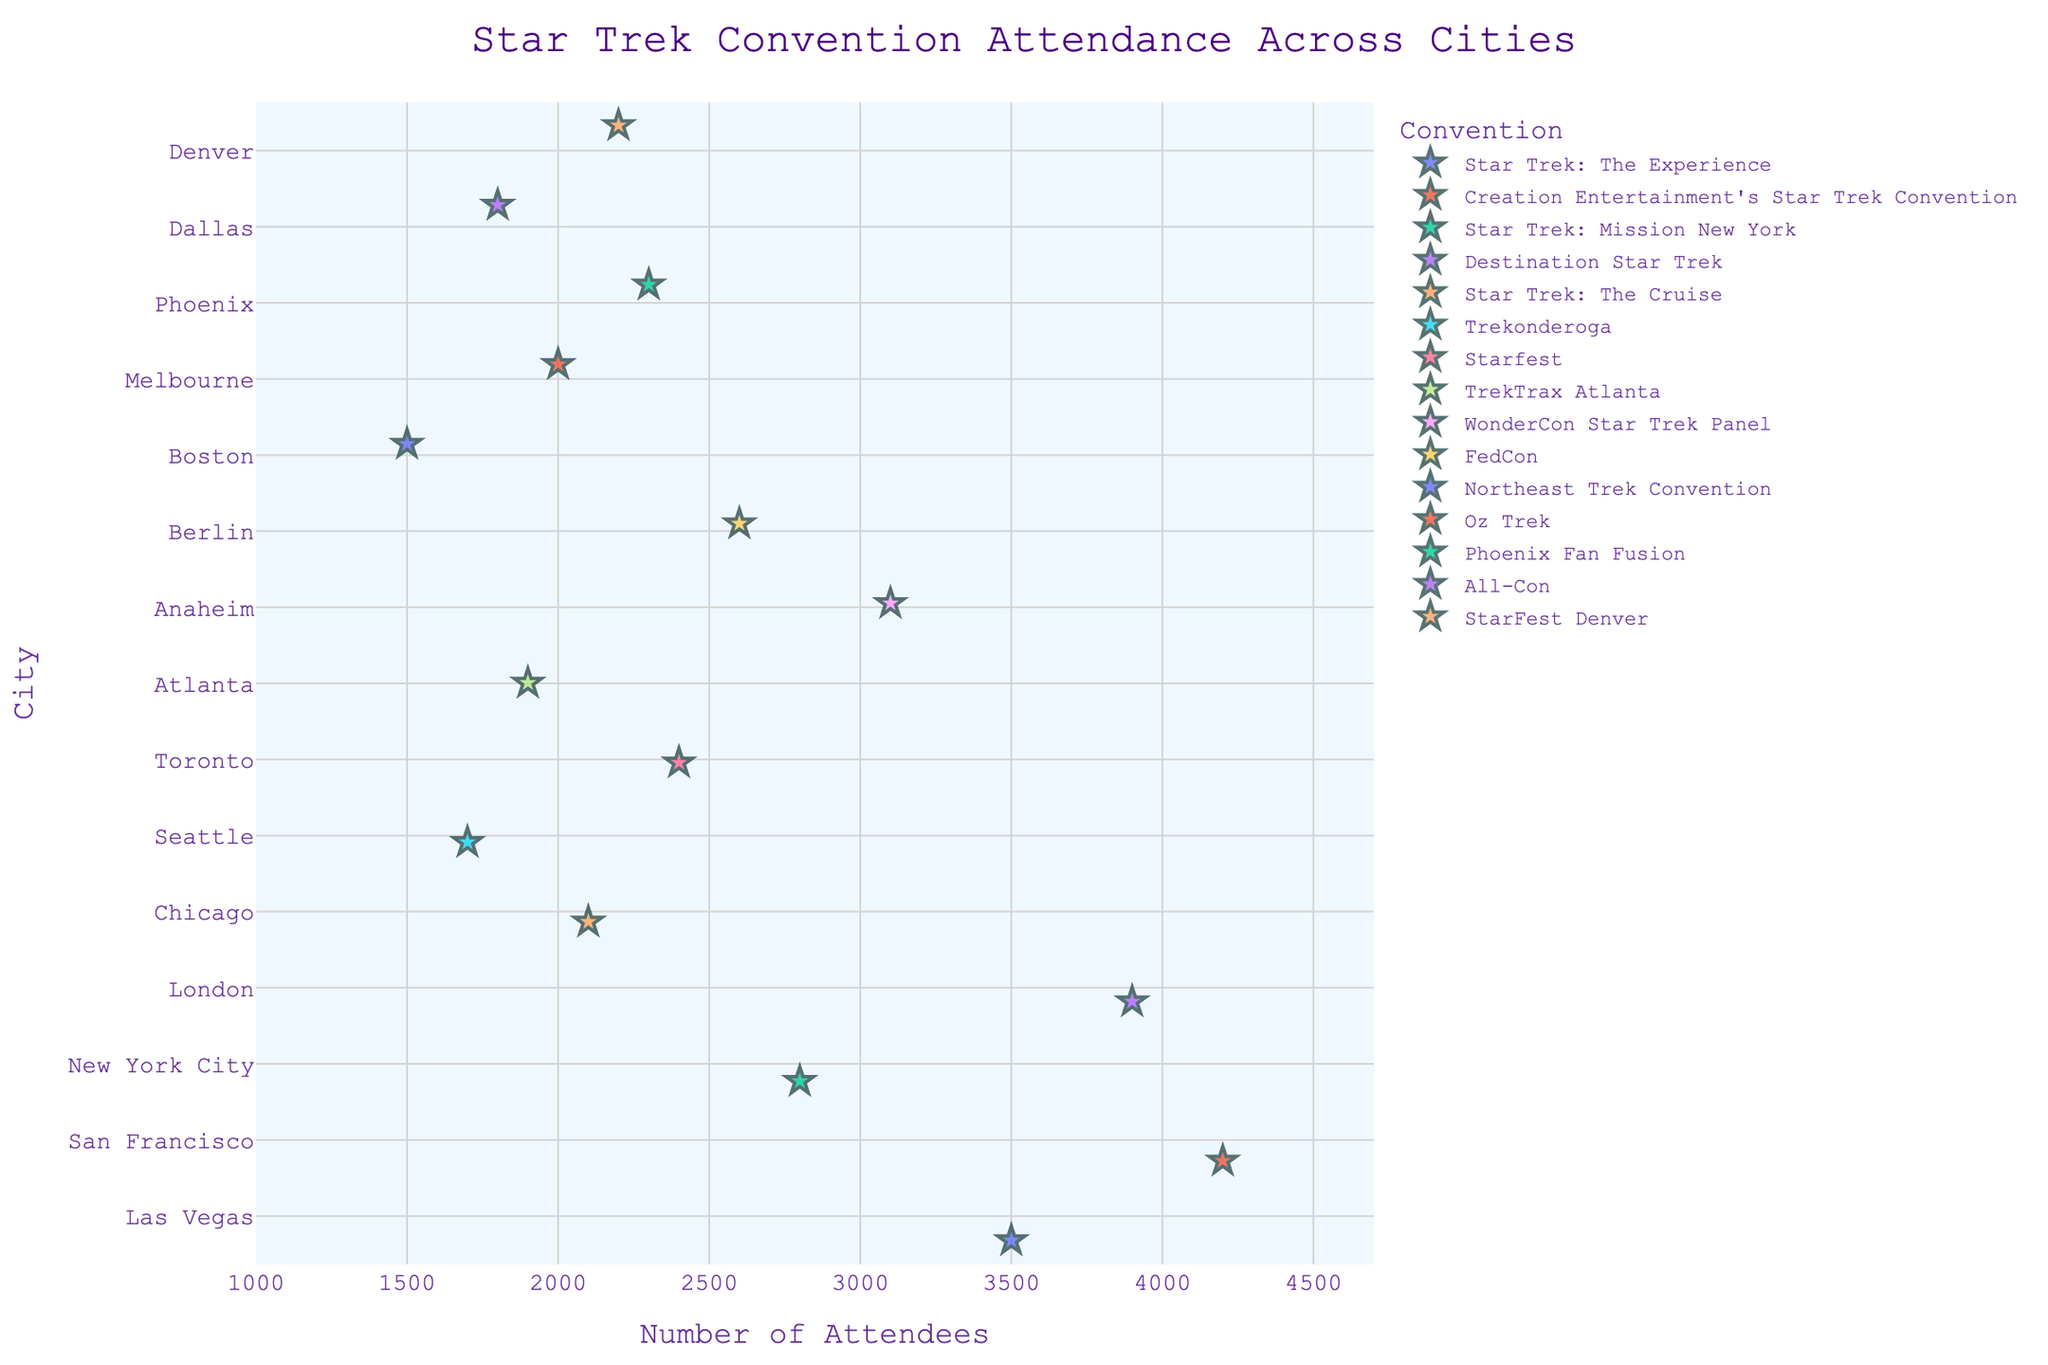How many cities are represented in the plot? Look at the y-axis to count the unique cities listed.
Answer: 15 What's the highest convention attendance, and in which city did it occur? Identify the point that is furthest to the right on the x-axis and then see which city it is aligned with on the y-axis.
Answer: 4200, San Francisco Which city had the lowest attendance, and what was the number? Identify the point that is furthest to the left on the x-axis and then see which city it is aligned with on the y-axis.
Answer: Boston, 1500 What is the range of attendance for the conventions shown? Subtract the smallest attendance value from the largest attendance value on the x-axis.
Answer: 4200 - 1500 = 2700 How many conventions had attendance greater than 3000? Count the number of points lying to the right side of the 3000 attendance mark on the x-axis.
Answer: 4 Which convention had the highest attendance, and what was the city? Look for the point with the highest x-axis value and identify the corresponding convention labeled by color and legend.
Answer: Creation Entertainment's Star Trek Convention, San Francisco Compare the attendance of "StarFest Denver" and "All-Con." Which one had more attendees and by how much? Identify the points for these conventions on the plot and compare their x-axis values. Then subtract the smaller attendance from the larger one.
Answer: StarFest Denver had more; difference is 2200 - 1800 = 400 What's the median attendance across all conventions? List out all the attendance values and find the middle value when sorted in ascending order.
Answer: 2200 Are there more conventions with attendance above or below 2500? Count the number of points on either side of the 2500 mark on the x-axis.
Answer: Below What's the average attendance for conventions hosted in cities starting with the letter 'L'? Find the attendance values for Las Vegas and London, sum them up, and divide by the number of cities.
Answer: (3500 + 3900) / 2 = 3700 